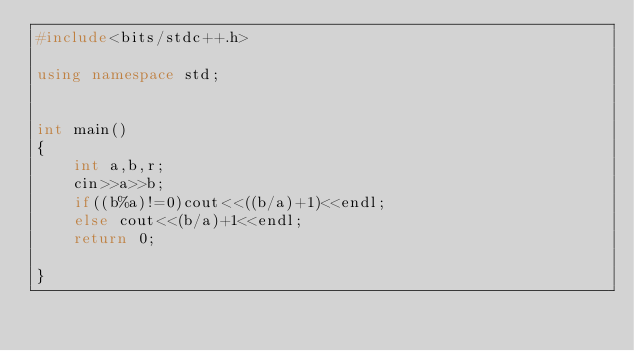<code> <loc_0><loc_0><loc_500><loc_500><_C++_>#include<bits/stdc++.h>

using namespace std;


int main()
{
    int a,b,r;
    cin>>a>>b;
    if((b%a)!=0)cout<<((b/a)+1)<<endl;
    else cout<<(b/a)+1<<endl;
    return 0;

}
</code> 